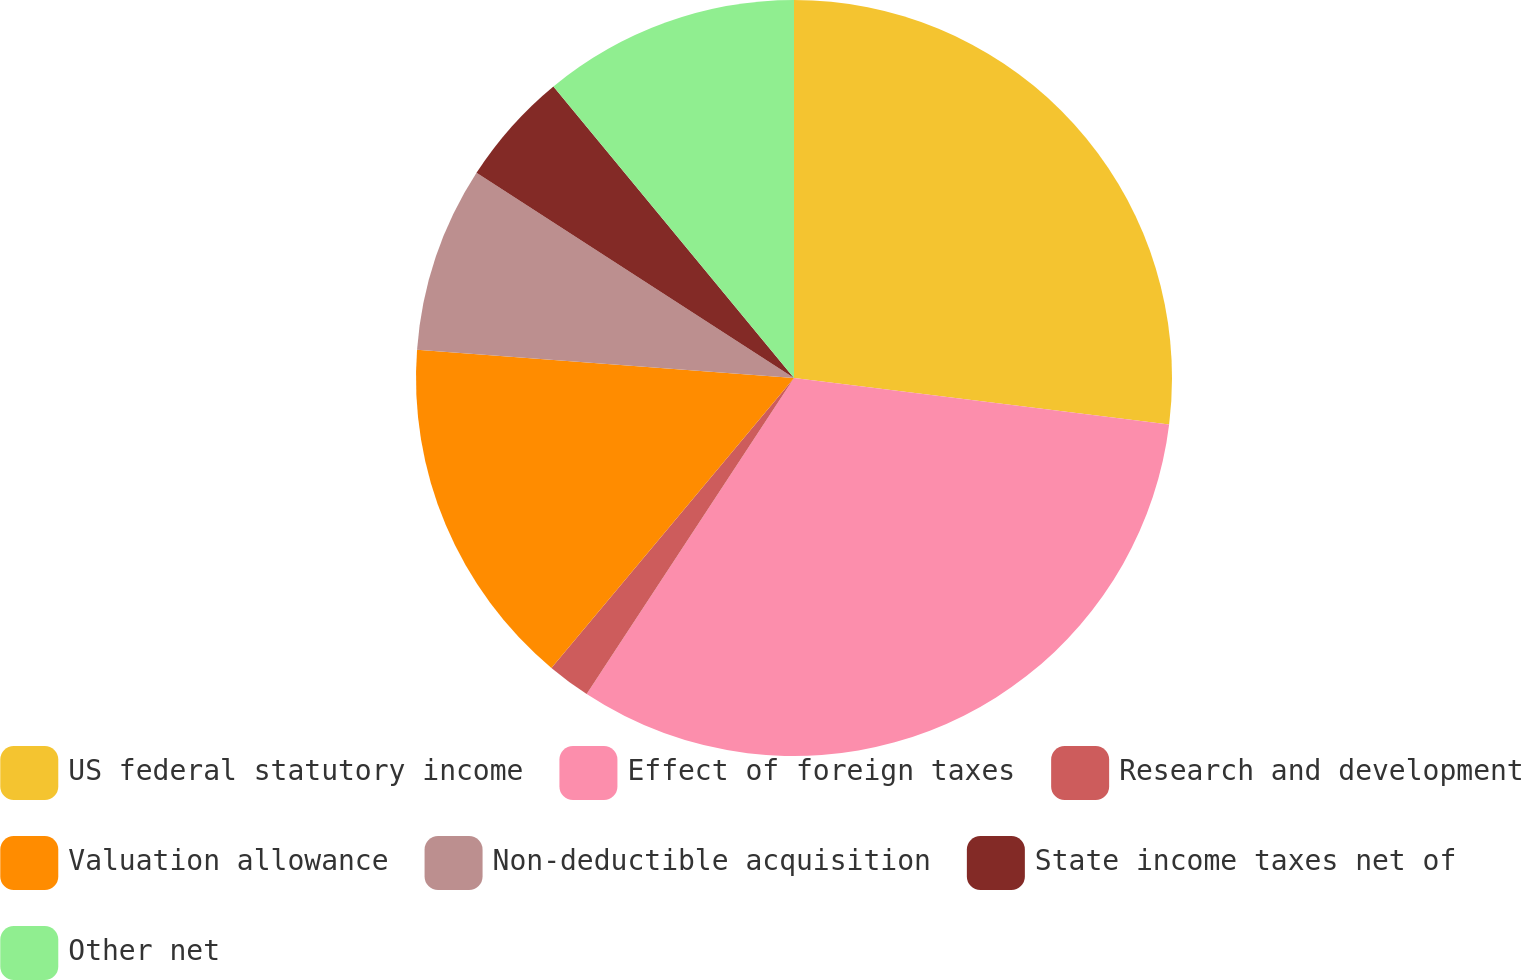Convert chart to OTSL. <chart><loc_0><loc_0><loc_500><loc_500><pie_chart><fcel>US federal statutory income<fcel>Effect of foreign taxes<fcel>Research and development<fcel>Valuation allowance<fcel>Non-deductible acquisition<fcel>State income taxes net of<fcel>Other net<nl><fcel>26.96%<fcel>32.28%<fcel>1.85%<fcel>15.1%<fcel>7.94%<fcel>4.89%<fcel>10.98%<nl></chart> 